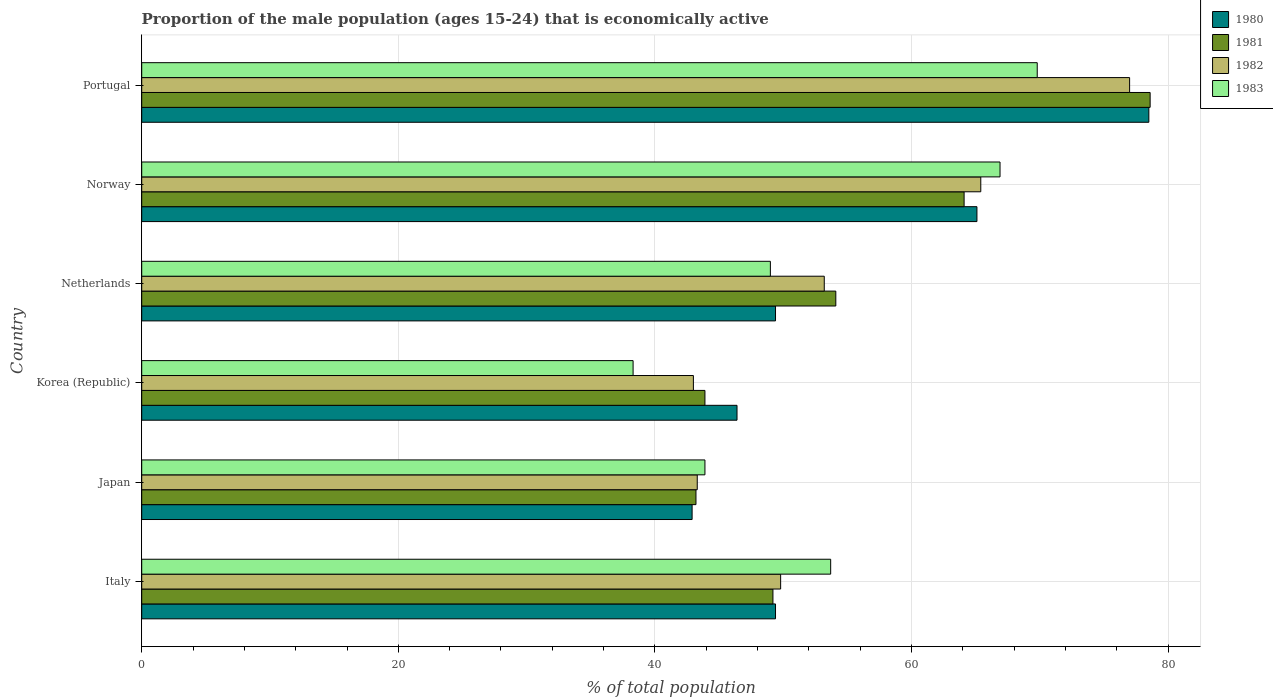How many groups of bars are there?
Provide a short and direct response. 6. Are the number of bars per tick equal to the number of legend labels?
Offer a terse response. Yes. Are the number of bars on each tick of the Y-axis equal?
Ensure brevity in your answer.  Yes. How many bars are there on the 3rd tick from the top?
Your response must be concise. 4. How many bars are there on the 3rd tick from the bottom?
Your response must be concise. 4. What is the label of the 6th group of bars from the top?
Offer a terse response. Italy. What is the proportion of the male population that is economically active in 1980 in Portugal?
Give a very brief answer. 78.5. Across all countries, what is the maximum proportion of the male population that is economically active in 1981?
Keep it short and to the point. 78.6. Across all countries, what is the minimum proportion of the male population that is economically active in 1981?
Offer a terse response. 43.2. In which country was the proportion of the male population that is economically active in 1981 maximum?
Your answer should be compact. Portugal. In which country was the proportion of the male population that is economically active in 1981 minimum?
Provide a short and direct response. Japan. What is the total proportion of the male population that is economically active in 1980 in the graph?
Make the answer very short. 331.7. What is the difference between the proportion of the male population that is economically active in 1981 in Italy and that in Norway?
Make the answer very short. -14.9. What is the difference between the proportion of the male population that is economically active in 1980 in Japan and the proportion of the male population that is economically active in 1983 in Italy?
Give a very brief answer. -10.8. What is the average proportion of the male population that is economically active in 1981 per country?
Ensure brevity in your answer.  55.52. What is the difference between the proportion of the male population that is economically active in 1980 and proportion of the male population that is economically active in 1983 in Netherlands?
Give a very brief answer. 0.4. In how many countries, is the proportion of the male population that is economically active in 1982 greater than 32 %?
Offer a terse response. 6. What is the ratio of the proportion of the male population that is economically active in 1983 in Korea (Republic) to that in Portugal?
Keep it short and to the point. 0.55. What is the difference between the highest and the second highest proportion of the male population that is economically active in 1980?
Provide a succinct answer. 13.4. What is the difference between the highest and the lowest proportion of the male population that is economically active in 1983?
Give a very brief answer. 31.5. In how many countries, is the proportion of the male population that is economically active in 1982 greater than the average proportion of the male population that is economically active in 1982 taken over all countries?
Make the answer very short. 2. What does the 2nd bar from the top in Italy represents?
Provide a succinct answer. 1982. How many bars are there?
Provide a succinct answer. 24. Are all the bars in the graph horizontal?
Your answer should be compact. Yes. How many countries are there in the graph?
Your answer should be compact. 6. How many legend labels are there?
Offer a very short reply. 4. What is the title of the graph?
Provide a short and direct response. Proportion of the male population (ages 15-24) that is economically active. What is the label or title of the X-axis?
Your response must be concise. % of total population. What is the label or title of the Y-axis?
Ensure brevity in your answer.  Country. What is the % of total population of 1980 in Italy?
Provide a short and direct response. 49.4. What is the % of total population in 1981 in Italy?
Keep it short and to the point. 49.2. What is the % of total population in 1982 in Italy?
Make the answer very short. 49.8. What is the % of total population in 1983 in Italy?
Your answer should be very brief. 53.7. What is the % of total population in 1980 in Japan?
Your answer should be very brief. 42.9. What is the % of total population of 1981 in Japan?
Offer a very short reply. 43.2. What is the % of total population in 1982 in Japan?
Your answer should be very brief. 43.3. What is the % of total population in 1983 in Japan?
Provide a succinct answer. 43.9. What is the % of total population of 1980 in Korea (Republic)?
Keep it short and to the point. 46.4. What is the % of total population of 1981 in Korea (Republic)?
Your answer should be compact. 43.9. What is the % of total population of 1983 in Korea (Republic)?
Offer a very short reply. 38.3. What is the % of total population of 1980 in Netherlands?
Give a very brief answer. 49.4. What is the % of total population of 1981 in Netherlands?
Your answer should be very brief. 54.1. What is the % of total population of 1982 in Netherlands?
Your answer should be very brief. 53.2. What is the % of total population of 1980 in Norway?
Your answer should be compact. 65.1. What is the % of total population of 1981 in Norway?
Your answer should be compact. 64.1. What is the % of total population in 1982 in Norway?
Keep it short and to the point. 65.4. What is the % of total population in 1983 in Norway?
Provide a succinct answer. 66.9. What is the % of total population of 1980 in Portugal?
Keep it short and to the point. 78.5. What is the % of total population of 1981 in Portugal?
Make the answer very short. 78.6. What is the % of total population of 1983 in Portugal?
Give a very brief answer. 69.8. Across all countries, what is the maximum % of total population in 1980?
Give a very brief answer. 78.5. Across all countries, what is the maximum % of total population in 1981?
Give a very brief answer. 78.6. Across all countries, what is the maximum % of total population of 1982?
Offer a terse response. 77. Across all countries, what is the maximum % of total population in 1983?
Offer a very short reply. 69.8. Across all countries, what is the minimum % of total population of 1980?
Keep it short and to the point. 42.9. Across all countries, what is the minimum % of total population in 1981?
Your answer should be very brief. 43.2. Across all countries, what is the minimum % of total population of 1983?
Give a very brief answer. 38.3. What is the total % of total population in 1980 in the graph?
Your answer should be very brief. 331.7. What is the total % of total population in 1981 in the graph?
Provide a short and direct response. 333.1. What is the total % of total population in 1982 in the graph?
Offer a terse response. 331.7. What is the total % of total population in 1983 in the graph?
Give a very brief answer. 321.6. What is the difference between the % of total population in 1981 in Italy and that in Japan?
Make the answer very short. 6. What is the difference between the % of total population in 1982 in Italy and that in Japan?
Your response must be concise. 6.5. What is the difference between the % of total population in 1983 in Italy and that in Japan?
Your response must be concise. 9.8. What is the difference between the % of total population in 1980 in Italy and that in Korea (Republic)?
Give a very brief answer. 3. What is the difference between the % of total population in 1980 in Italy and that in Netherlands?
Your response must be concise. 0. What is the difference between the % of total population of 1983 in Italy and that in Netherlands?
Give a very brief answer. 4.7. What is the difference between the % of total population in 1980 in Italy and that in Norway?
Your answer should be compact. -15.7. What is the difference between the % of total population in 1981 in Italy and that in Norway?
Keep it short and to the point. -14.9. What is the difference between the % of total population in 1982 in Italy and that in Norway?
Your answer should be compact. -15.6. What is the difference between the % of total population in 1983 in Italy and that in Norway?
Your response must be concise. -13.2. What is the difference between the % of total population of 1980 in Italy and that in Portugal?
Offer a very short reply. -29.1. What is the difference between the % of total population of 1981 in Italy and that in Portugal?
Your answer should be very brief. -29.4. What is the difference between the % of total population in 1982 in Italy and that in Portugal?
Keep it short and to the point. -27.2. What is the difference between the % of total population of 1983 in Italy and that in Portugal?
Keep it short and to the point. -16.1. What is the difference between the % of total population of 1981 in Japan and that in Korea (Republic)?
Give a very brief answer. -0.7. What is the difference between the % of total population of 1982 in Japan and that in Korea (Republic)?
Keep it short and to the point. 0.3. What is the difference between the % of total population of 1983 in Japan and that in Korea (Republic)?
Make the answer very short. 5.6. What is the difference between the % of total population of 1980 in Japan and that in Netherlands?
Your answer should be very brief. -6.5. What is the difference between the % of total population in 1983 in Japan and that in Netherlands?
Ensure brevity in your answer.  -5.1. What is the difference between the % of total population in 1980 in Japan and that in Norway?
Offer a very short reply. -22.2. What is the difference between the % of total population in 1981 in Japan and that in Norway?
Provide a short and direct response. -20.9. What is the difference between the % of total population of 1982 in Japan and that in Norway?
Provide a succinct answer. -22.1. What is the difference between the % of total population in 1980 in Japan and that in Portugal?
Offer a very short reply. -35.6. What is the difference between the % of total population in 1981 in Japan and that in Portugal?
Keep it short and to the point. -35.4. What is the difference between the % of total population in 1982 in Japan and that in Portugal?
Make the answer very short. -33.7. What is the difference between the % of total population in 1983 in Japan and that in Portugal?
Your answer should be very brief. -25.9. What is the difference between the % of total population in 1982 in Korea (Republic) and that in Netherlands?
Your answer should be compact. -10.2. What is the difference between the % of total population in 1983 in Korea (Republic) and that in Netherlands?
Your answer should be very brief. -10.7. What is the difference between the % of total population of 1980 in Korea (Republic) and that in Norway?
Offer a very short reply. -18.7. What is the difference between the % of total population in 1981 in Korea (Republic) and that in Norway?
Offer a terse response. -20.2. What is the difference between the % of total population of 1982 in Korea (Republic) and that in Norway?
Ensure brevity in your answer.  -22.4. What is the difference between the % of total population in 1983 in Korea (Republic) and that in Norway?
Your answer should be compact. -28.6. What is the difference between the % of total population of 1980 in Korea (Republic) and that in Portugal?
Provide a short and direct response. -32.1. What is the difference between the % of total population in 1981 in Korea (Republic) and that in Portugal?
Your answer should be very brief. -34.7. What is the difference between the % of total population of 1982 in Korea (Republic) and that in Portugal?
Provide a short and direct response. -34. What is the difference between the % of total population of 1983 in Korea (Republic) and that in Portugal?
Offer a very short reply. -31.5. What is the difference between the % of total population in 1980 in Netherlands and that in Norway?
Provide a succinct answer. -15.7. What is the difference between the % of total population of 1981 in Netherlands and that in Norway?
Ensure brevity in your answer.  -10. What is the difference between the % of total population in 1982 in Netherlands and that in Norway?
Offer a terse response. -12.2. What is the difference between the % of total population in 1983 in Netherlands and that in Norway?
Provide a short and direct response. -17.9. What is the difference between the % of total population in 1980 in Netherlands and that in Portugal?
Offer a very short reply. -29.1. What is the difference between the % of total population in 1981 in Netherlands and that in Portugal?
Give a very brief answer. -24.5. What is the difference between the % of total population of 1982 in Netherlands and that in Portugal?
Provide a short and direct response. -23.8. What is the difference between the % of total population in 1983 in Netherlands and that in Portugal?
Your response must be concise. -20.8. What is the difference between the % of total population of 1981 in Norway and that in Portugal?
Keep it short and to the point. -14.5. What is the difference between the % of total population in 1982 in Norway and that in Portugal?
Offer a very short reply. -11.6. What is the difference between the % of total population of 1981 in Italy and the % of total population of 1982 in Japan?
Keep it short and to the point. 5.9. What is the difference between the % of total population of 1981 in Italy and the % of total population of 1983 in Japan?
Offer a terse response. 5.3. What is the difference between the % of total population in 1982 in Italy and the % of total population in 1983 in Japan?
Offer a very short reply. 5.9. What is the difference between the % of total population of 1980 in Italy and the % of total population of 1981 in Korea (Republic)?
Ensure brevity in your answer.  5.5. What is the difference between the % of total population of 1980 in Italy and the % of total population of 1982 in Korea (Republic)?
Ensure brevity in your answer.  6.4. What is the difference between the % of total population of 1981 in Italy and the % of total population of 1982 in Korea (Republic)?
Ensure brevity in your answer.  6.2. What is the difference between the % of total population in 1980 in Italy and the % of total population in 1981 in Norway?
Your answer should be very brief. -14.7. What is the difference between the % of total population in 1980 in Italy and the % of total population in 1983 in Norway?
Make the answer very short. -17.5. What is the difference between the % of total population of 1981 in Italy and the % of total population of 1982 in Norway?
Provide a succinct answer. -16.2. What is the difference between the % of total population of 1981 in Italy and the % of total population of 1983 in Norway?
Give a very brief answer. -17.7. What is the difference between the % of total population in 1982 in Italy and the % of total population in 1983 in Norway?
Keep it short and to the point. -17.1. What is the difference between the % of total population in 1980 in Italy and the % of total population in 1981 in Portugal?
Provide a succinct answer. -29.2. What is the difference between the % of total population of 1980 in Italy and the % of total population of 1982 in Portugal?
Provide a short and direct response. -27.6. What is the difference between the % of total population in 1980 in Italy and the % of total population in 1983 in Portugal?
Your response must be concise. -20.4. What is the difference between the % of total population in 1981 in Italy and the % of total population in 1982 in Portugal?
Ensure brevity in your answer.  -27.8. What is the difference between the % of total population in 1981 in Italy and the % of total population in 1983 in Portugal?
Make the answer very short. -20.6. What is the difference between the % of total population of 1980 in Japan and the % of total population of 1981 in Korea (Republic)?
Your answer should be compact. -1. What is the difference between the % of total population in 1981 in Japan and the % of total population in 1983 in Korea (Republic)?
Give a very brief answer. 4.9. What is the difference between the % of total population of 1982 in Japan and the % of total population of 1983 in Korea (Republic)?
Provide a short and direct response. 5. What is the difference between the % of total population in 1980 in Japan and the % of total population in 1981 in Netherlands?
Make the answer very short. -11.2. What is the difference between the % of total population in 1980 in Japan and the % of total population in 1983 in Netherlands?
Your answer should be very brief. -6.1. What is the difference between the % of total population in 1980 in Japan and the % of total population in 1981 in Norway?
Provide a short and direct response. -21.2. What is the difference between the % of total population of 1980 in Japan and the % of total population of 1982 in Norway?
Provide a short and direct response. -22.5. What is the difference between the % of total population in 1980 in Japan and the % of total population in 1983 in Norway?
Provide a succinct answer. -24. What is the difference between the % of total population of 1981 in Japan and the % of total population of 1982 in Norway?
Offer a terse response. -22.2. What is the difference between the % of total population of 1981 in Japan and the % of total population of 1983 in Norway?
Your answer should be very brief. -23.7. What is the difference between the % of total population of 1982 in Japan and the % of total population of 1983 in Norway?
Give a very brief answer. -23.6. What is the difference between the % of total population in 1980 in Japan and the % of total population in 1981 in Portugal?
Make the answer very short. -35.7. What is the difference between the % of total population of 1980 in Japan and the % of total population of 1982 in Portugal?
Offer a terse response. -34.1. What is the difference between the % of total population of 1980 in Japan and the % of total population of 1983 in Portugal?
Make the answer very short. -26.9. What is the difference between the % of total population of 1981 in Japan and the % of total population of 1982 in Portugal?
Keep it short and to the point. -33.8. What is the difference between the % of total population in 1981 in Japan and the % of total population in 1983 in Portugal?
Give a very brief answer. -26.6. What is the difference between the % of total population of 1982 in Japan and the % of total population of 1983 in Portugal?
Your response must be concise. -26.5. What is the difference between the % of total population in 1980 in Korea (Republic) and the % of total population in 1983 in Netherlands?
Give a very brief answer. -2.6. What is the difference between the % of total population of 1981 in Korea (Republic) and the % of total population of 1983 in Netherlands?
Ensure brevity in your answer.  -5.1. What is the difference between the % of total population in 1982 in Korea (Republic) and the % of total population in 1983 in Netherlands?
Your answer should be compact. -6. What is the difference between the % of total population in 1980 in Korea (Republic) and the % of total population in 1981 in Norway?
Your answer should be compact. -17.7. What is the difference between the % of total population of 1980 in Korea (Republic) and the % of total population of 1982 in Norway?
Make the answer very short. -19. What is the difference between the % of total population of 1980 in Korea (Republic) and the % of total population of 1983 in Norway?
Provide a short and direct response. -20.5. What is the difference between the % of total population of 1981 in Korea (Republic) and the % of total population of 1982 in Norway?
Make the answer very short. -21.5. What is the difference between the % of total population of 1982 in Korea (Republic) and the % of total population of 1983 in Norway?
Offer a terse response. -23.9. What is the difference between the % of total population in 1980 in Korea (Republic) and the % of total population in 1981 in Portugal?
Provide a short and direct response. -32.2. What is the difference between the % of total population in 1980 in Korea (Republic) and the % of total population in 1982 in Portugal?
Your answer should be very brief. -30.6. What is the difference between the % of total population in 1980 in Korea (Republic) and the % of total population in 1983 in Portugal?
Offer a terse response. -23.4. What is the difference between the % of total population of 1981 in Korea (Republic) and the % of total population of 1982 in Portugal?
Provide a short and direct response. -33.1. What is the difference between the % of total population of 1981 in Korea (Republic) and the % of total population of 1983 in Portugal?
Give a very brief answer. -25.9. What is the difference between the % of total population in 1982 in Korea (Republic) and the % of total population in 1983 in Portugal?
Offer a terse response. -26.8. What is the difference between the % of total population of 1980 in Netherlands and the % of total population of 1981 in Norway?
Your answer should be compact. -14.7. What is the difference between the % of total population of 1980 in Netherlands and the % of total population of 1983 in Norway?
Make the answer very short. -17.5. What is the difference between the % of total population in 1982 in Netherlands and the % of total population in 1983 in Norway?
Ensure brevity in your answer.  -13.7. What is the difference between the % of total population of 1980 in Netherlands and the % of total population of 1981 in Portugal?
Keep it short and to the point. -29.2. What is the difference between the % of total population in 1980 in Netherlands and the % of total population in 1982 in Portugal?
Offer a terse response. -27.6. What is the difference between the % of total population of 1980 in Netherlands and the % of total population of 1983 in Portugal?
Make the answer very short. -20.4. What is the difference between the % of total population of 1981 in Netherlands and the % of total population of 1982 in Portugal?
Ensure brevity in your answer.  -22.9. What is the difference between the % of total population of 1981 in Netherlands and the % of total population of 1983 in Portugal?
Offer a very short reply. -15.7. What is the difference between the % of total population of 1982 in Netherlands and the % of total population of 1983 in Portugal?
Ensure brevity in your answer.  -16.6. What is the difference between the % of total population of 1980 in Norway and the % of total population of 1981 in Portugal?
Give a very brief answer. -13.5. What is the difference between the % of total population of 1980 in Norway and the % of total population of 1982 in Portugal?
Ensure brevity in your answer.  -11.9. What is the difference between the % of total population in 1980 in Norway and the % of total population in 1983 in Portugal?
Give a very brief answer. -4.7. What is the difference between the % of total population of 1981 in Norway and the % of total population of 1982 in Portugal?
Keep it short and to the point. -12.9. What is the difference between the % of total population in 1982 in Norway and the % of total population in 1983 in Portugal?
Provide a short and direct response. -4.4. What is the average % of total population in 1980 per country?
Your answer should be very brief. 55.28. What is the average % of total population of 1981 per country?
Ensure brevity in your answer.  55.52. What is the average % of total population of 1982 per country?
Your response must be concise. 55.28. What is the average % of total population of 1983 per country?
Your answer should be compact. 53.6. What is the difference between the % of total population of 1980 and % of total population of 1981 in Italy?
Offer a terse response. 0.2. What is the difference between the % of total population in 1980 and % of total population in 1982 in Italy?
Keep it short and to the point. -0.4. What is the difference between the % of total population of 1981 and % of total population of 1982 in Italy?
Make the answer very short. -0.6. What is the difference between the % of total population of 1981 and % of total population of 1983 in Italy?
Make the answer very short. -4.5. What is the difference between the % of total population of 1982 and % of total population of 1983 in Italy?
Make the answer very short. -3.9. What is the difference between the % of total population in 1980 and % of total population in 1983 in Japan?
Offer a terse response. -1. What is the difference between the % of total population of 1980 and % of total population of 1982 in Korea (Republic)?
Provide a short and direct response. 3.4. What is the difference between the % of total population of 1980 and % of total population of 1983 in Korea (Republic)?
Your answer should be compact. 8.1. What is the difference between the % of total population in 1980 and % of total population in 1983 in Netherlands?
Provide a succinct answer. 0.4. What is the difference between the % of total population in 1981 and % of total population in 1982 in Netherlands?
Your answer should be compact. 0.9. What is the difference between the % of total population of 1980 and % of total population of 1981 in Norway?
Keep it short and to the point. 1. What is the difference between the % of total population in 1980 and % of total population in 1982 in Norway?
Your answer should be compact. -0.3. What is the difference between the % of total population in 1982 and % of total population in 1983 in Norway?
Your answer should be compact. -1.5. What is the difference between the % of total population in 1980 and % of total population in 1981 in Portugal?
Make the answer very short. -0.1. What is the difference between the % of total population of 1980 and % of total population of 1982 in Portugal?
Offer a terse response. 1.5. What is the difference between the % of total population in 1980 and % of total population in 1983 in Portugal?
Offer a terse response. 8.7. What is the difference between the % of total population in 1982 and % of total population in 1983 in Portugal?
Your answer should be very brief. 7.2. What is the ratio of the % of total population in 1980 in Italy to that in Japan?
Your answer should be compact. 1.15. What is the ratio of the % of total population in 1981 in Italy to that in Japan?
Offer a very short reply. 1.14. What is the ratio of the % of total population of 1982 in Italy to that in Japan?
Offer a very short reply. 1.15. What is the ratio of the % of total population in 1983 in Italy to that in Japan?
Give a very brief answer. 1.22. What is the ratio of the % of total population of 1980 in Italy to that in Korea (Republic)?
Offer a terse response. 1.06. What is the ratio of the % of total population in 1981 in Italy to that in Korea (Republic)?
Keep it short and to the point. 1.12. What is the ratio of the % of total population of 1982 in Italy to that in Korea (Republic)?
Keep it short and to the point. 1.16. What is the ratio of the % of total population in 1983 in Italy to that in Korea (Republic)?
Your answer should be very brief. 1.4. What is the ratio of the % of total population in 1981 in Italy to that in Netherlands?
Your answer should be very brief. 0.91. What is the ratio of the % of total population in 1982 in Italy to that in Netherlands?
Offer a terse response. 0.94. What is the ratio of the % of total population of 1983 in Italy to that in Netherlands?
Provide a short and direct response. 1.1. What is the ratio of the % of total population of 1980 in Italy to that in Norway?
Your answer should be very brief. 0.76. What is the ratio of the % of total population in 1981 in Italy to that in Norway?
Ensure brevity in your answer.  0.77. What is the ratio of the % of total population of 1982 in Italy to that in Norway?
Your answer should be very brief. 0.76. What is the ratio of the % of total population in 1983 in Italy to that in Norway?
Provide a short and direct response. 0.8. What is the ratio of the % of total population of 1980 in Italy to that in Portugal?
Your answer should be compact. 0.63. What is the ratio of the % of total population in 1981 in Italy to that in Portugal?
Offer a terse response. 0.63. What is the ratio of the % of total population in 1982 in Italy to that in Portugal?
Ensure brevity in your answer.  0.65. What is the ratio of the % of total population in 1983 in Italy to that in Portugal?
Make the answer very short. 0.77. What is the ratio of the % of total population of 1980 in Japan to that in Korea (Republic)?
Make the answer very short. 0.92. What is the ratio of the % of total population of 1981 in Japan to that in Korea (Republic)?
Offer a very short reply. 0.98. What is the ratio of the % of total population in 1983 in Japan to that in Korea (Republic)?
Give a very brief answer. 1.15. What is the ratio of the % of total population in 1980 in Japan to that in Netherlands?
Your answer should be very brief. 0.87. What is the ratio of the % of total population of 1981 in Japan to that in Netherlands?
Keep it short and to the point. 0.8. What is the ratio of the % of total population in 1982 in Japan to that in Netherlands?
Ensure brevity in your answer.  0.81. What is the ratio of the % of total population in 1983 in Japan to that in Netherlands?
Provide a short and direct response. 0.9. What is the ratio of the % of total population of 1980 in Japan to that in Norway?
Offer a terse response. 0.66. What is the ratio of the % of total population of 1981 in Japan to that in Norway?
Offer a very short reply. 0.67. What is the ratio of the % of total population in 1982 in Japan to that in Norway?
Provide a succinct answer. 0.66. What is the ratio of the % of total population of 1983 in Japan to that in Norway?
Your answer should be compact. 0.66. What is the ratio of the % of total population in 1980 in Japan to that in Portugal?
Your answer should be compact. 0.55. What is the ratio of the % of total population in 1981 in Japan to that in Portugal?
Make the answer very short. 0.55. What is the ratio of the % of total population in 1982 in Japan to that in Portugal?
Ensure brevity in your answer.  0.56. What is the ratio of the % of total population in 1983 in Japan to that in Portugal?
Offer a very short reply. 0.63. What is the ratio of the % of total population in 1980 in Korea (Republic) to that in Netherlands?
Ensure brevity in your answer.  0.94. What is the ratio of the % of total population in 1981 in Korea (Republic) to that in Netherlands?
Your response must be concise. 0.81. What is the ratio of the % of total population in 1982 in Korea (Republic) to that in Netherlands?
Keep it short and to the point. 0.81. What is the ratio of the % of total population in 1983 in Korea (Republic) to that in Netherlands?
Offer a terse response. 0.78. What is the ratio of the % of total population in 1980 in Korea (Republic) to that in Norway?
Your answer should be very brief. 0.71. What is the ratio of the % of total population in 1981 in Korea (Republic) to that in Norway?
Provide a short and direct response. 0.68. What is the ratio of the % of total population of 1982 in Korea (Republic) to that in Norway?
Provide a short and direct response. 0.66. What is the ratio of the % of total population in 1983 in Korea (Republic) to that in Norway?
Offer a terse response. 0.57. What is the ratio of the % of total population of 1980 in Korea (Republic) to that in Portugal?
Offer a terse response. 0.59. What is the ratio of the % of total population in 1981 in Korea (Republic) to that in Portugal?
Offer a terse response. 0.56. What is the ratio of the % of total population of 1982 in Korea (Republic) to that in Portugal?
Your response must be concise. 0.56. What is the ratio of the % of total population of 1983 in Korea (Republic) to that in Portugal?
Ensure brevity in your answer.  0.55. What is the ratio of the % of total population of 1980 in Netherlands to that in Norway?
Keep it short and to the point. 0.76. What is the ratio of the % of total population of 1981 in Netherlands to that in Norway?
Your answer should be very brief. 0.84. What is the ratio of the % of total population of 1982 in Netherlands to that in Norway?
Keep it short and to the point. 0.81. What is the ratio of the % of total population of 1983 in Netherlands to that in Norway?
Offer a very short reply. 0.73. What is the ratio of the % of total population in 1980 in Netherlands to that in Portugal?
Keep it short and to the point. 0.63. What is the ratio of the % of total population of 1981 in Netherlands to that in Portugal?
Offer a terse response. 0.69. What is the ratio of the % of total population in 1982 in Netherlands to that in Portugal?
Provide a succinct answer. 0.69. What is the ratio of the % of total population in 1983 in Netherlands to that in Portugal?
Make the answer very short. 0.7. What is the ratio of the % of total population of 1980 in Norway to that in Portugal?
Keep it short and to the point. 0.83. What is the ratio of the % of total population in 1981 in Norway to that in Portugal?
Provide a short and direct response. 0.82. What is the ratio of the % of total population of 1982 in Norway to that in Portugal?
Offer a very short reply. 0.85. What is the ratio of the % of total population of 1983 in Norway to that in Portugal?
Offer a terse response. 0.96. What is the difference between the highest and the second highest % of total population in 1981?
Offer a terse response. 14.5. What is the difference between the highest and the second highest % of total population in 1982?
Offer a terse response. 11.6. What is the difference between the highest and the lowest % of total population in 1980?
Offer a very short reply. 35.6. What is the difference between the highest and the lowest % of total population of 1981?
Offer a terse response. 35.4. What is the difference between the highest and the lowest % of total population of 1982?
Your response must be concise. 34. What is the difference between the highest and the lowest % of total population in 1983?
Make the answer very short. 31.5. 